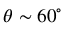Convert formula to latex. <formula><loc_0><loc_0><loc_500><loc_500>\theta \sim 6 0 ^ { \circ }</formula> 